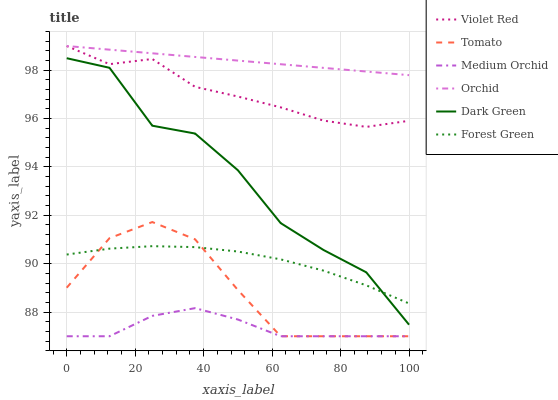Does Medium Orchid have the minimum area under the curve?
Answer yes or no. Yes. Does Orchid have the maximum area under the curve?
Answer yes or no. Yes. Does Violet Red have the minimum area under the curve?
Answer yes or no. No. Does Violet Red have the maximum area under the curve?
Answer yes or no. No. Is Orchid the smoothest?
Answer yes or no. Yes. Is Dark Green the roughest?
Answer yes or no. Yes. Is Violet Red the smoothest?
Answer yes or no. No. Is Violet Red the roughest?
Answer yes or no. No. Does Tomato have the lowest value?
Answer yes or no. Yes. Does Violet Red have the lowest value?
Answer yes or no. No. Does Orchid have the highest value?
Answer yes or no. Yes. Does Medium Orchid have the highest value?
Answer yes or no. No. Is Medium Orchid less than Orchid?
Answer yes or no. Yes. Is Violet Red greater than Forest Green?
Answer yes or no. Yes. Does Forest Green intersect Dark Green?
Answer yes or no. Yes. Is Forest Green less than Dark Green?
Answer yes or no. No. Is Forest Green greater than Dark Green?
Answer yes or no. No. Does Medium Orchid intersect Orchid?
Answer yes or no. No. 